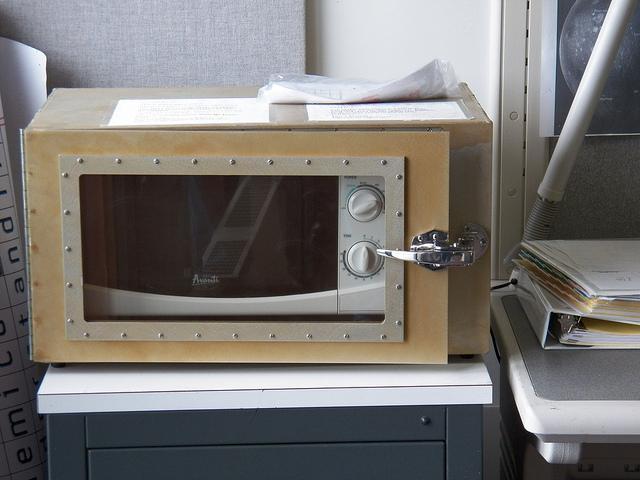How many microwaves can be seen?
Give a very brief answer. 1. How many books are in the photo?
Give a very brief answer. 2. 